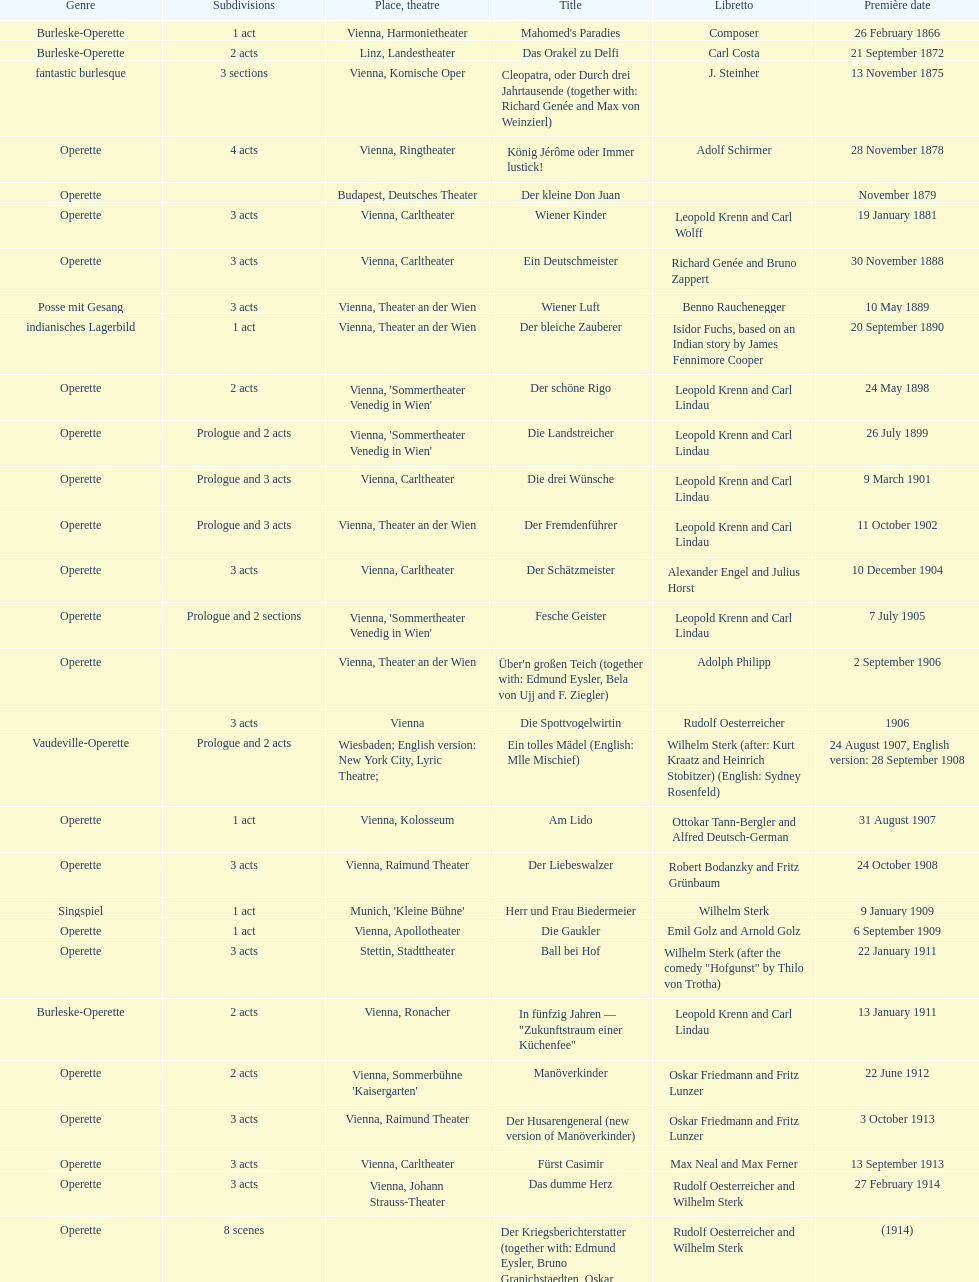How many of his operettas were 3 acts? 13. 